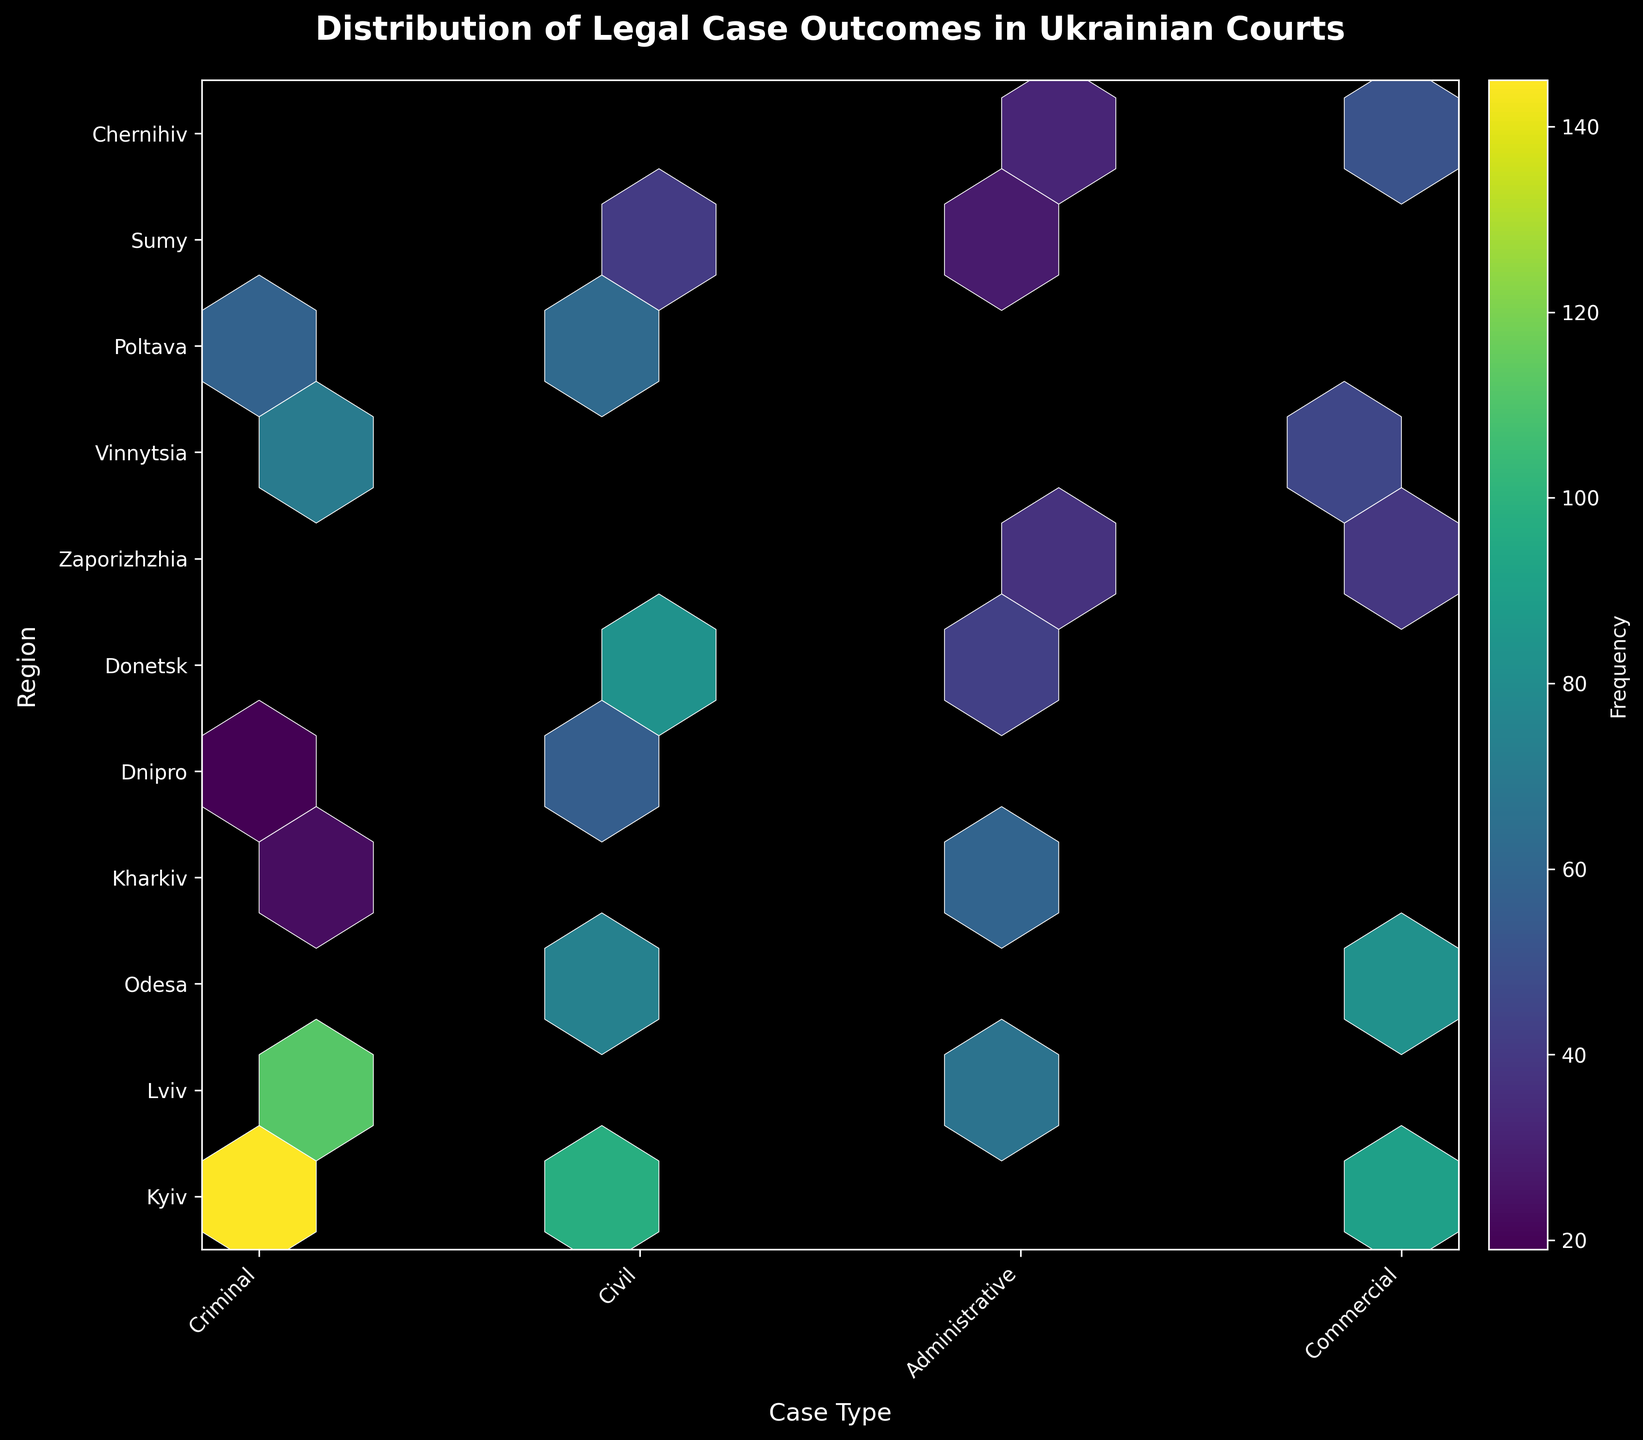What is the title of the hexbin plot? The title of the figure can be found at the top, which describes the content and purpose of the plot.
Answer: Distribution of Legal Case Outcomes in Ukrainian Courts Which axis represents the regions in the plot? The regions are represented along the vertical axis as indicated by the axis labels.
Answer: The vertical axis What color is used to represent the highest frequency in the plot? The color that represents the highest frequency can be determined by looking at the color bar and finding the color corresponding to the highest value.
Answer: A bright yellow color How many case types are displayed on the horizontal axis? The number of case types can be counted by looking at the unique labels on the horizontal axis.
Answer: Four case types Which region has the highest frequency overall in the hexbin plot? To find the region with the highest frequency, locate the region on the vertical axis where the brightest hexagons (highest frequency) are concentrated.
Answer: Kyiv What is the frequency shown for the commercial case type in the Odesa region? Locate the intersection (hexbin) of the 'Commercial' case type on the horizontal axis and 'Odesa' region on the vertical axis, and refer to the color bar to determine the frequency.
Answer: 82 Which region has a higher frequency of administrative cases: Lviv or Donetsk? Compare the hexbin frequencies from the color bar for administrative cases in the Lviv and Donetsk regions to see which is higher.
Answer: Lviv How does the frequency of civil cases in Donetsk compare to that in Poltava? Compare the hexbin frequencies from the color bar for civil cases in Donetsk and Poltava regions.
Answer: Higher in Donetsk What is the frequency range utilizing the color bar in the hexbin plot? The frequency range can be determined by looking at the minimum and maximum values displayed on the color bar.
Answer: From a few to over 140 What is the overall trend for criminal cases across different regions in this plot? By observing the color differences among hexagons related to criminal cases across all regions, describe the overall trend.
Answer: Highly variable, peaks in Kyiv and Lviv 